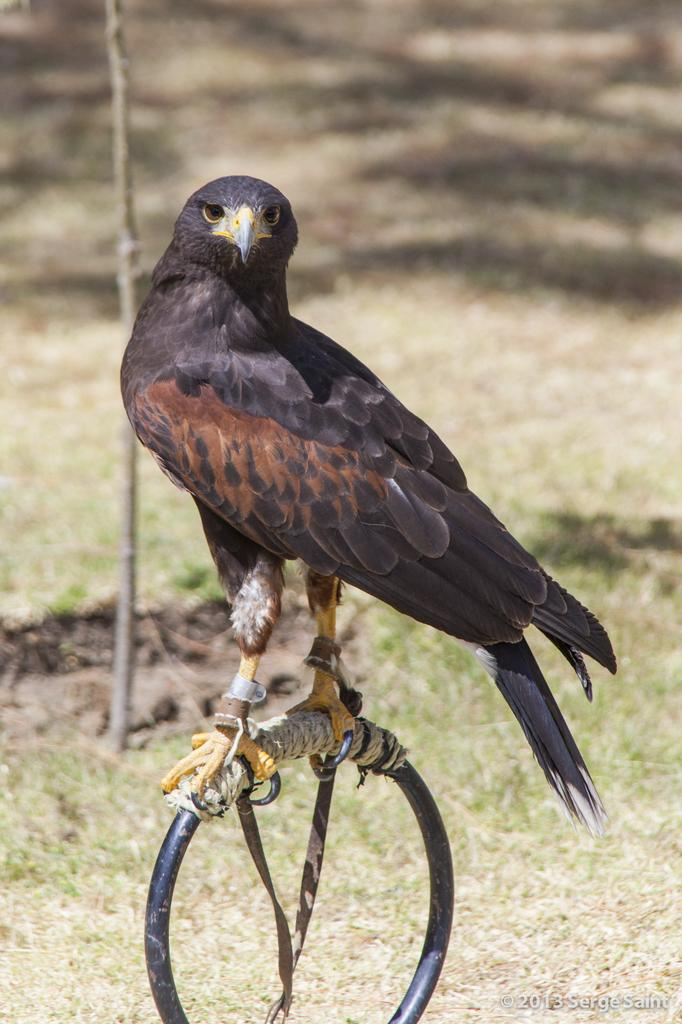What type of animal is in the image? There is a bird in the image. What is the bird standing on? The bird is standing on a ring. What is attached to the ring? There is a thread on the ring. What can be seen at the bottom of the image? The ground is visible at the bottom of the image. What is in the background of the image? There is a stick in the background of the image. What hour is the bird indicating with its beak in the image? The bird is not indicating an hour in the image; it is simply standing on a ring with a thread attached. 